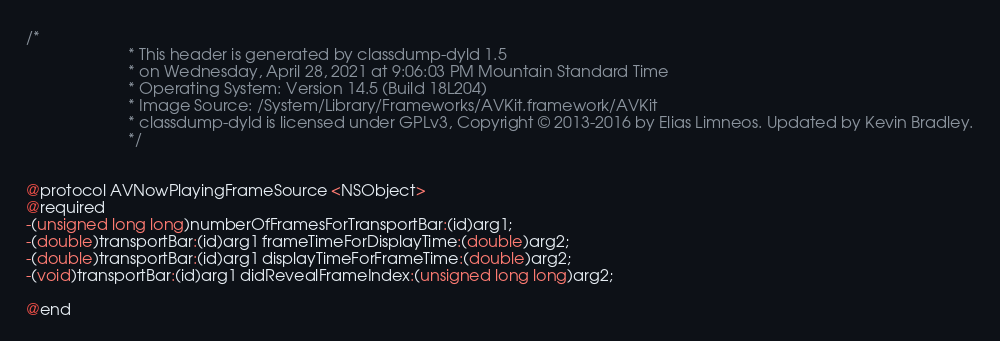Convert code to text. <code><loc_0><loc_0><loc_500><loc_500><_C_>/*
                       * This header is generated by classdump-dyld 1.5
                       * on Wednesday, April 28, 2021 at 9:06:03 PM Mountain Standard Time
                       * Operating System: Version 14.5 (Build 18L204)
                       * Image Source: /System/Library/Frameworks/AVKit.framework/AVKit
                       * classdump-dyld is licensed under GPLv3, Copyright © 2013-2016 by Elias Limneos. Updated by Kevin Bradley.
                       */


@protocol AVNowPlayingFrameSource <NSObject>
@required
-(unsigned long long)numberOfFramesForTransportBar:(id)arg1;
-(double)transportBar:(id)arg1 frameTimeForDisplayTime:(double)arg2;
-(double)transportBar:(id)arg1 displayTimeForFrameTime:(double)arg2;
-(void)transportBar:(id)arg1 didRevealFrameIndex:(unsigned long long)arg2;

@end

</code> 